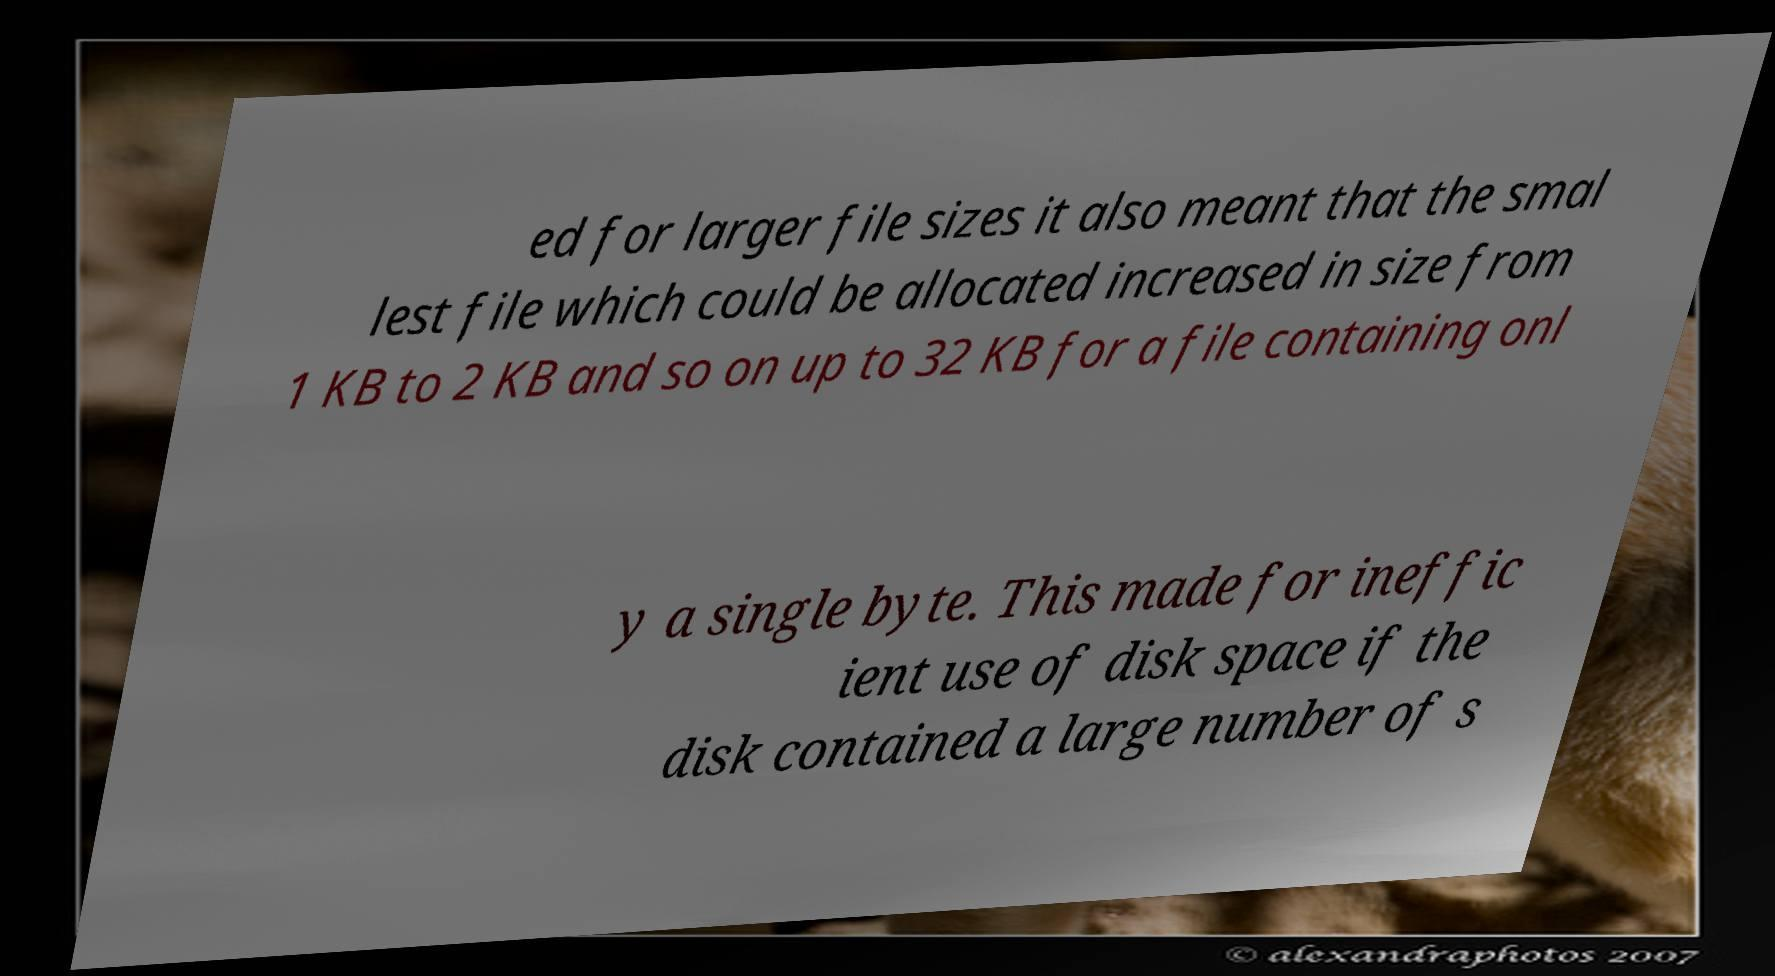There's text embedded in this image that I need extracted. Can you transcribe it verbatim? ed for larger file sizes it also meant that the smal lest file which could be allocated increased in size from 1 KB to 2 KB and so on up to 32 KB for a file containing onl y a single byte. This made for ineffic ient use of disk space if the disk contained a large number of s 